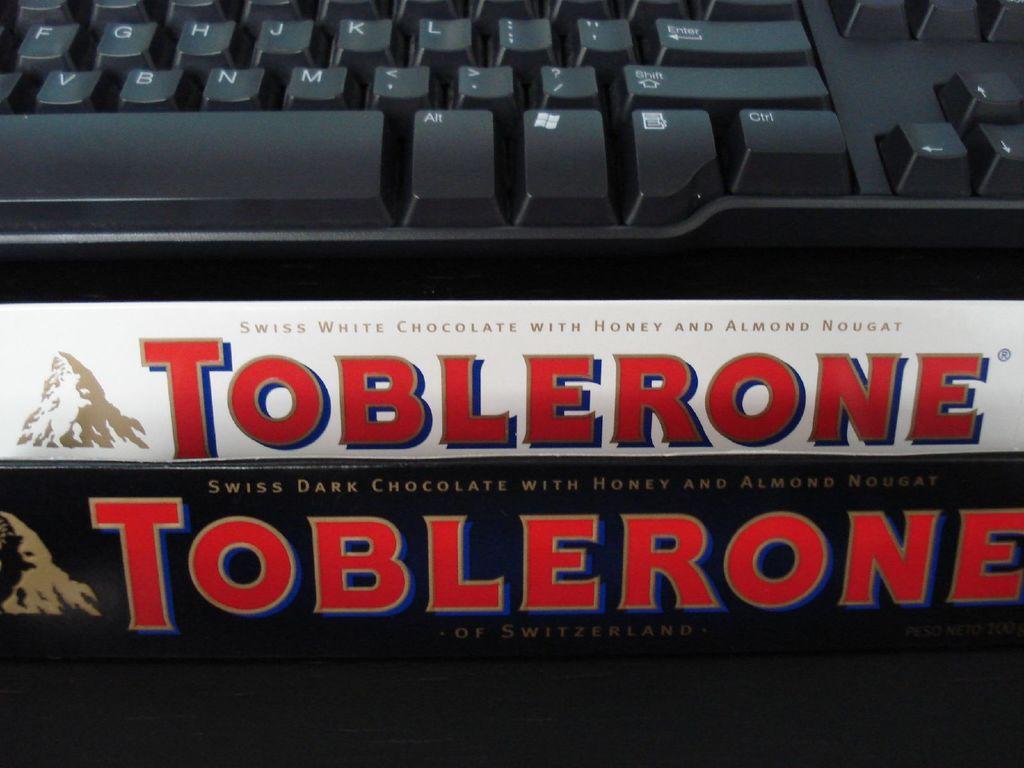What is the brand of the bottom bar?
Give a very brief answer. Toblerone. 